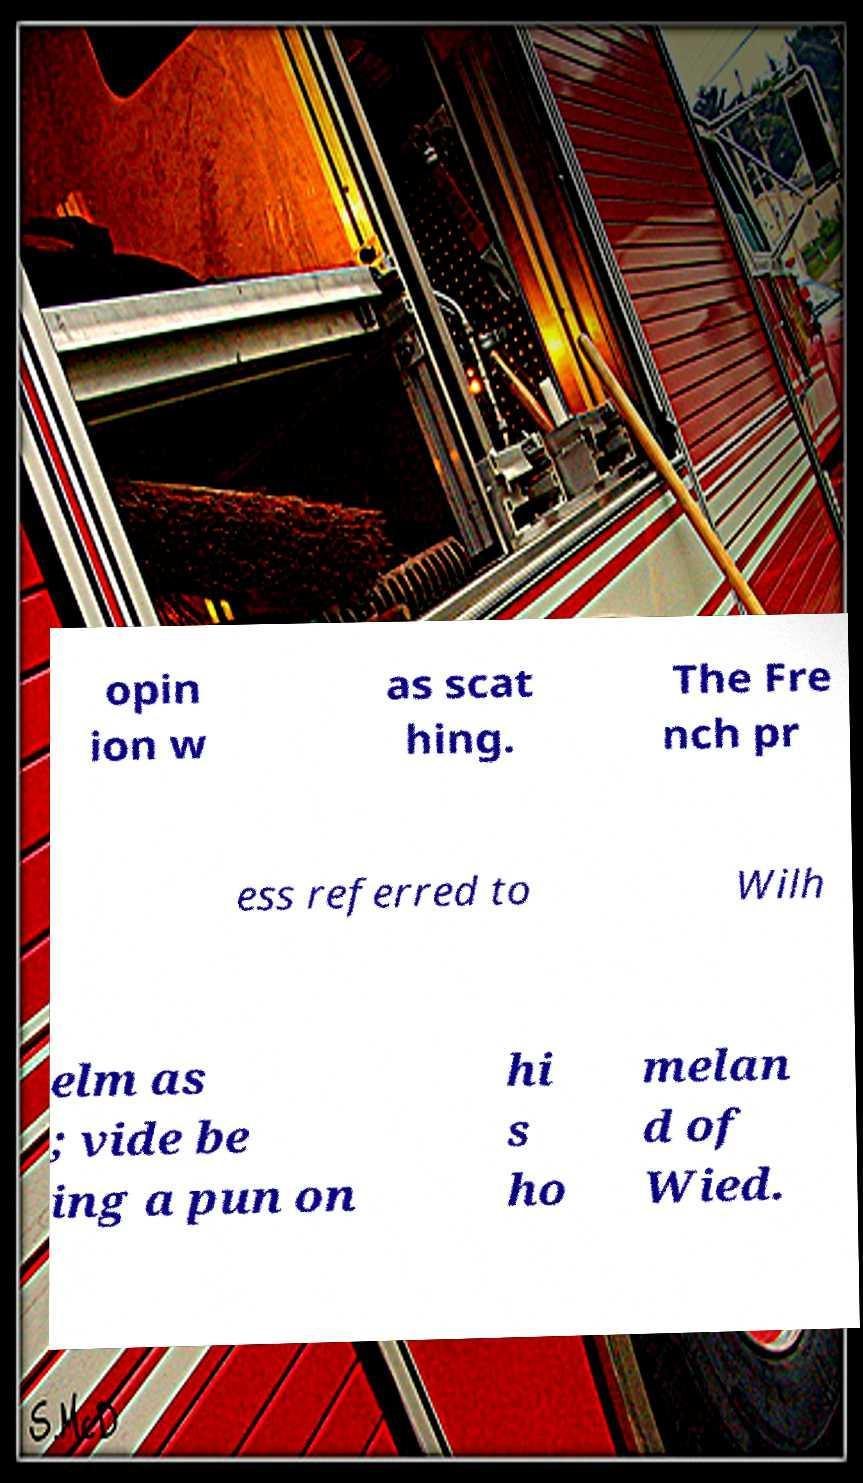What messages or text are displayed in this image? I need them in a readable, typed format. opin ion w as scat hing. The Fre nch pr ess referred to Wilh elm as ; vide be ing a pun on hi s ho melan d of Wied. 